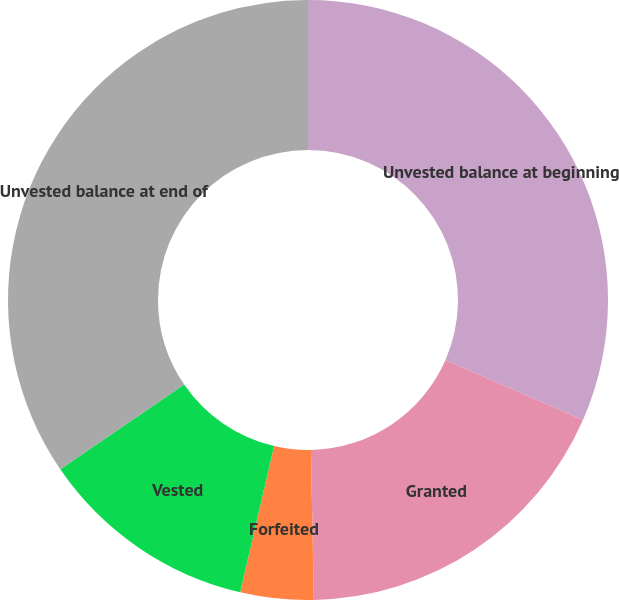<chart> <loc_0><loc_0><loc_500><loc_500><pie_chart><fcel>Unvested balance at beginning<fcel>Granted<fcel>Forfeited<fcel>Vested<fcel>Unvested balance at end of<nl><fcel>31.55%<fcel>18.14%<fcel>3.94%<fcel>11.83%<fcel>34.54%<nl></chart> 